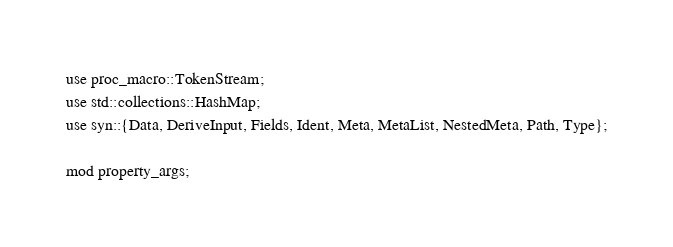Convert code to text. <code><loc_0><loc_0><loc_500><loc_500><_Rust_>use proc_macro::TokenStream;
use std::collections::HashMap;
use syn::{Data, DeriveInput, Fields, Ident, Meta, MetaList, NestedMeta, Path, Type};

mod property_args;</code> 